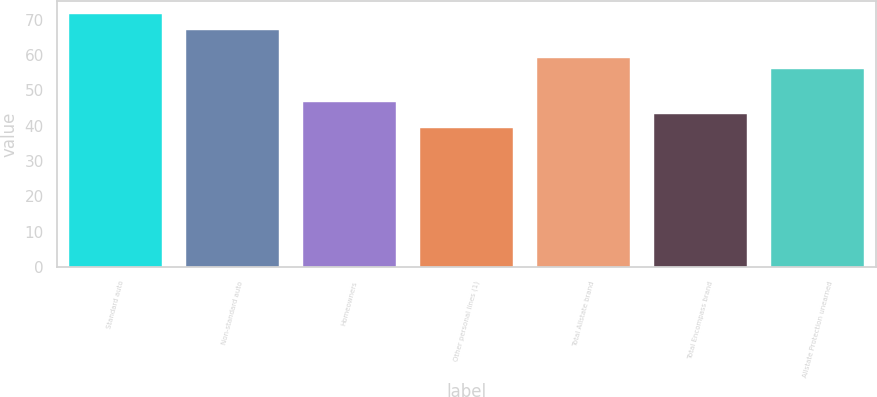Convert chart to OTSL. <chart><loc_0><loc_0><loc_500><loc_500><bar_chart><fcel>Standard auto<fcel>Non-standard auto<fcel>Homeowners<fcel>Other personal lines (1)<fcel>Total Allstate brand<fcel>Total Encompass brand<fcel>Allstate Protection unearned<nl><fcel>71.6<fcel>67.1<fcel>46.62<fcel>39.4<fcel>59.22<fcel>43.4<fcel>56<nl></chart> 